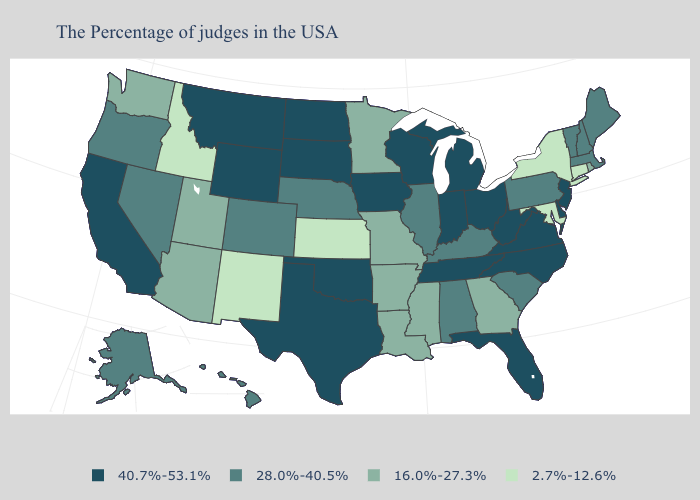Which states have the lowest value in the MidWest?
Concise answer only. Kansas. Name the states that have a value in the range 2.7%-12.6%?
Answer briefly. Connecticut, New York, Maryland, Kansas, New Mexico, Idaho. Does Indiana have the highest value in the USA?
Short answer required. Yes. What is the lowest value in the USA?
Quick response, please. 2.7%-12.6%. What is the value of Vermont?
Short answer required. 28.0%-40.5%. What is the value of Oregon?
Give a very brief answer. 28.0%-40.5%. Does Florida have a higher value than Missouri?
Concise answer only. Yes. Which states hav the highest value in the South?
Quick response, please. Delaware, Virginia, North Carolina, West Virginia, Florida, Tennessee, Oklahoma, Texas. What is the lowest value in the Northeast?
Write a very short answer. 2.7%-12.6%. Name the states that have a value in the range 28.0%-40.5%?
Concise answer only. Maine, Massachusetts, New Hampshire, Vermont, Pennsylvania, South Carolina, Kentucky, Alabama, Illinois, Nebraska, Colorado, Nevada, Oregon, Alaska, Hawaii. How many symbols are there in the legend?
Write a very short answer. 4. Among the states that border Oregon , does California have the highest value?
Keep it brief. Yes. What is the value of Wyoming?
Short answer required. 40.7%-53.1%. What is the lowest value in the Northeast?
Concise answer only. 2.7%-12.6%. What is the value of Montana?
Concise answer only. 40.7%-53.1%. 